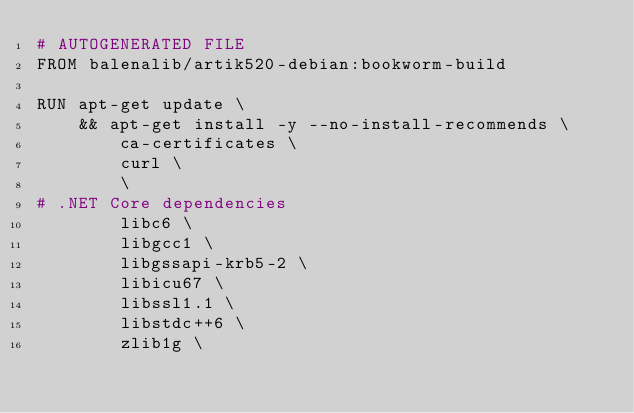<code> <loc_0><loc_0><loc_500><loc_500><_Dockerfile_># AUTOGENERATED FILE
FROM balenalib/artik520-debian:bookworm-build

RUN apt-get update \
    && apt-get install -y --no-install-recommends \
        ca-certificates \
        curl \
        \
# .NET Core dependencies
        libc6 \
        libgcc1 \
        libgssapi-krb5-2 \
        libicu67 \
        libssl1.1 \
        libstdc++6 \
        zlib1g \</code> 